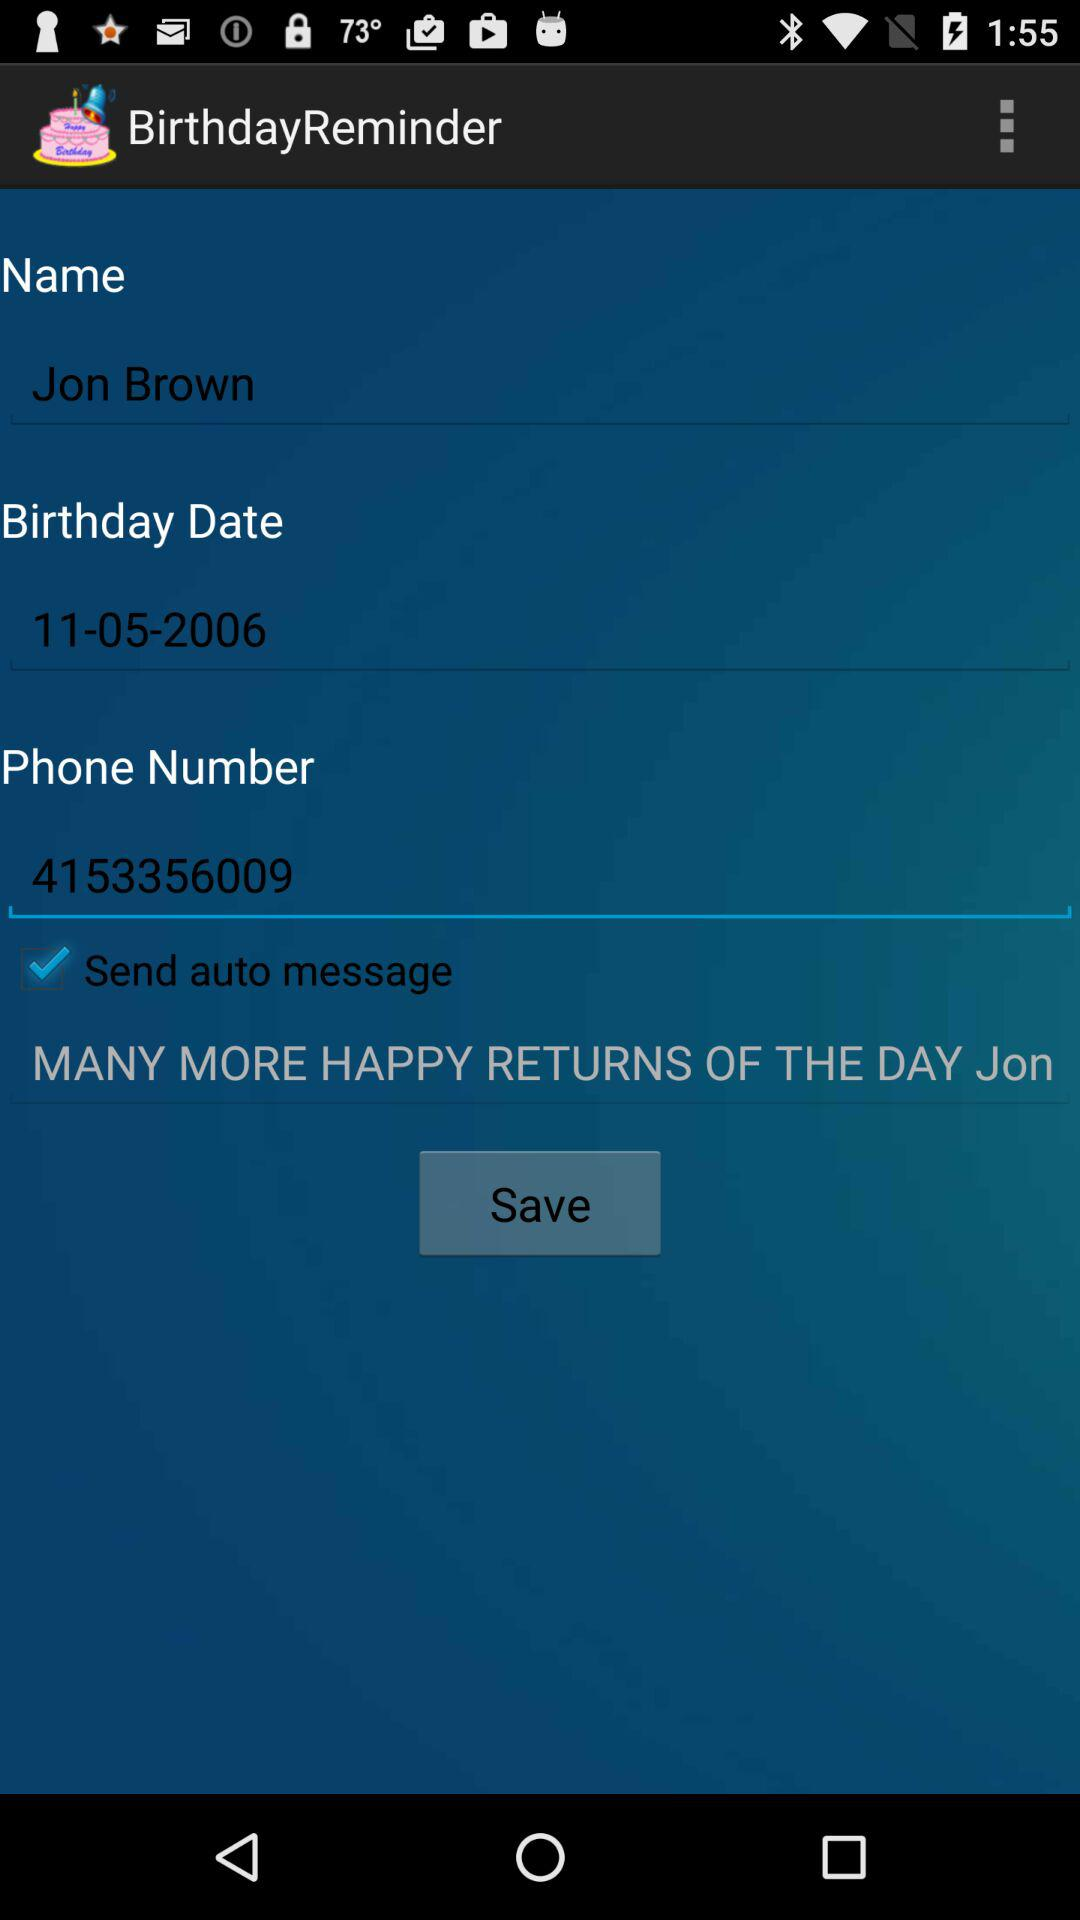What's the name? The name is Jon Brown. 